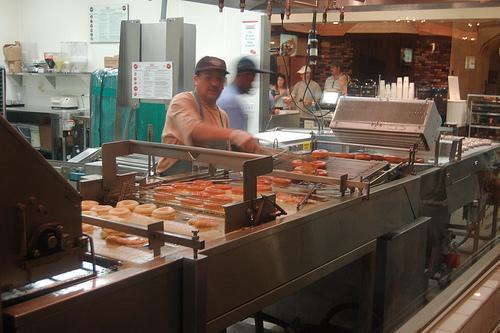How many people are there?
Give a very brief answer. 5. How many of the people are workers?
Give a very brief answer. 2. 